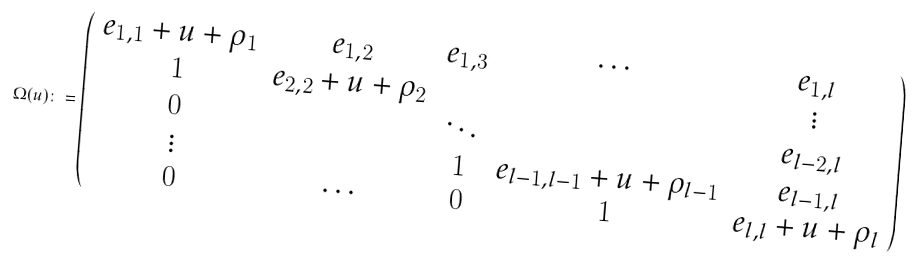Convert formula to latex. <formula><loc_0><loc_0><loc_500><loc_500>\Omega ( u ) \colon = \left ( \begin{array} { c c c c c c } e _ { 1 , 1 } + u + \rho _ { 1 } & e _ { 1 , 2 } & e _ { 1 , 3 } & \cdots & e _ { 1 , l } \\ 1 & e _ { 2 , 2 } + u + \rho _ { 2 } & & & \vdots \\ 0 & & \ddots & & e _ { l - 2 , l } \\ \vdots & & 1 & e _ { l - 1 , l - 1 } + u + \rho _ { l - 1 } & e _ { l - 1 , l } \\ 0 & \cdots & 0 & 1 & e _ { l , l } + u + \rho _ { l } \end{array} \right )</formula> 